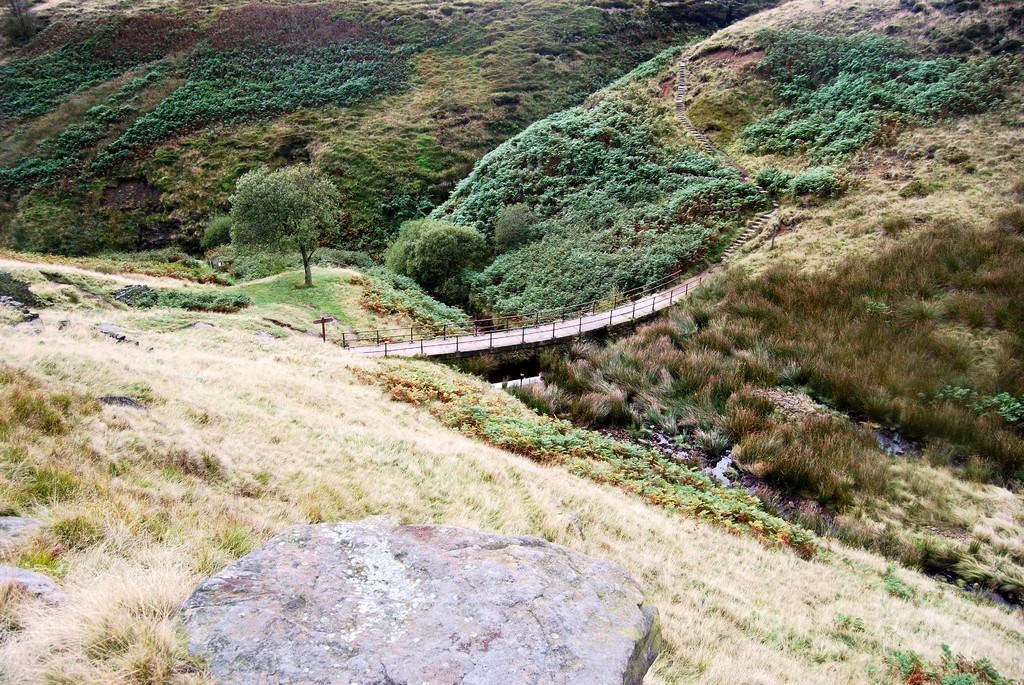What type of natural elements can be seen in the image? There are rocks and trees in the image. What type of man-made structure is present in the image? There is a bridge in the image. What is the desire of the parent in the image? There is no parent or indication of desire present in the image. What causes the people in the image to laugh? There are no people or indication of laughter present in the image. 